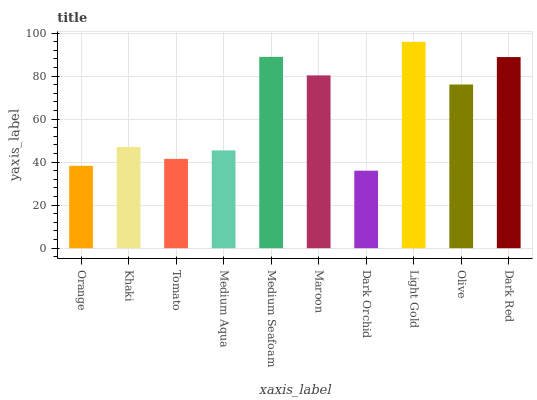Is Khaki the minimum?
Answer yes or no. No. Is Khaki the maximum?
Answer yes or no. No. Is Khaki greater than Orange?
Answer yes or no. Yes. Is Orange less than Khaki?
Answer yes or no. Yes. Is Orange greater than Khaki?
Answer yes or no. No. Is Khaki less than Orange?
Answer yes or no. No. Is Olive the high median?
Answer yes or no. Yes. Is Khaki the low median?
Answer yes or no. Yes. Is Medium Aqua the high median?
Answer yes or no. No. Is Maroon the low median?
Answer yes or no. No. 